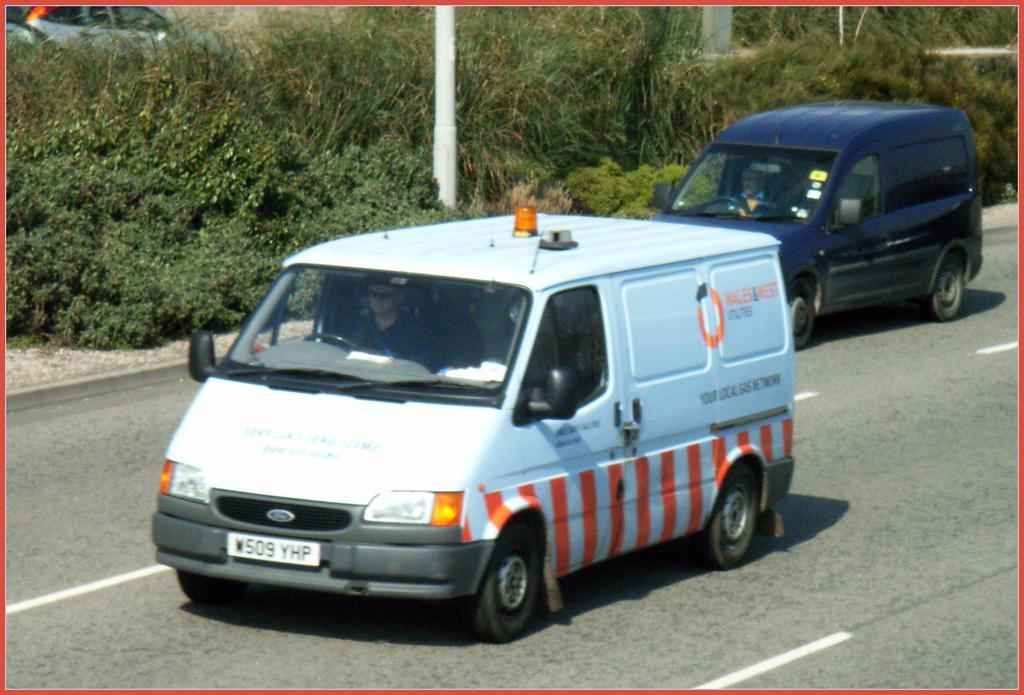Describe this image in one or two sentences. In this image we can see two persons sitting in vehicles parked on the road. In the background, we can see a vehicle, pole and a group of trees. 